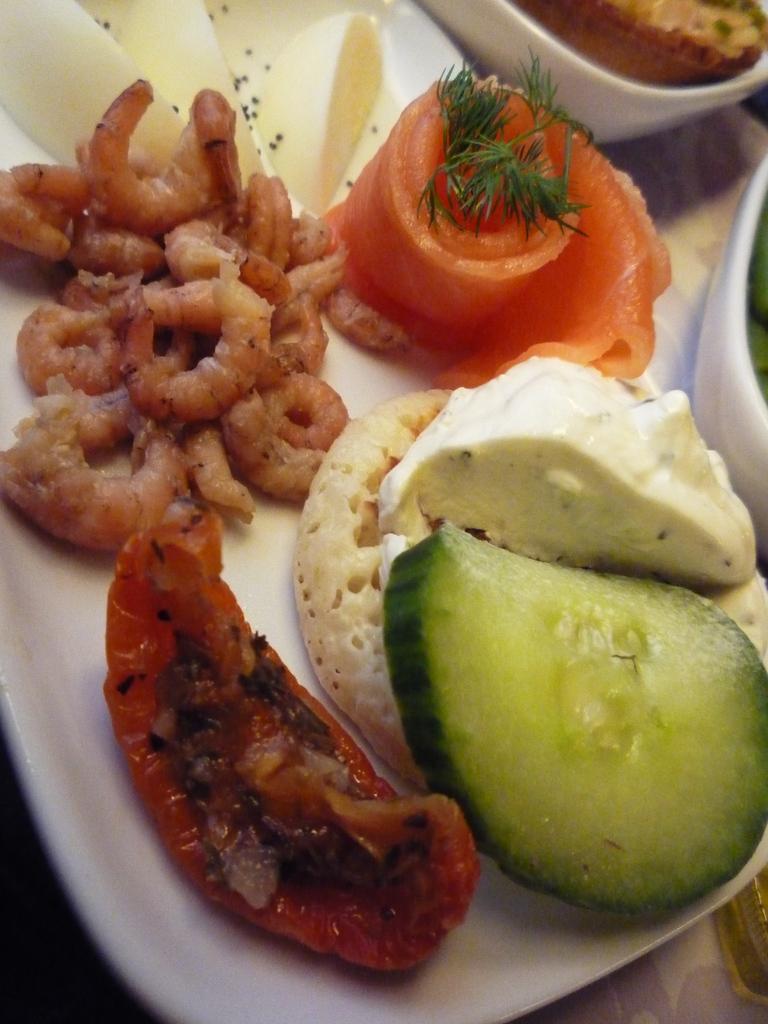Describe this image in one or two sentences. Here we can see food items and two bowls with food in it on a plate on the platform. 